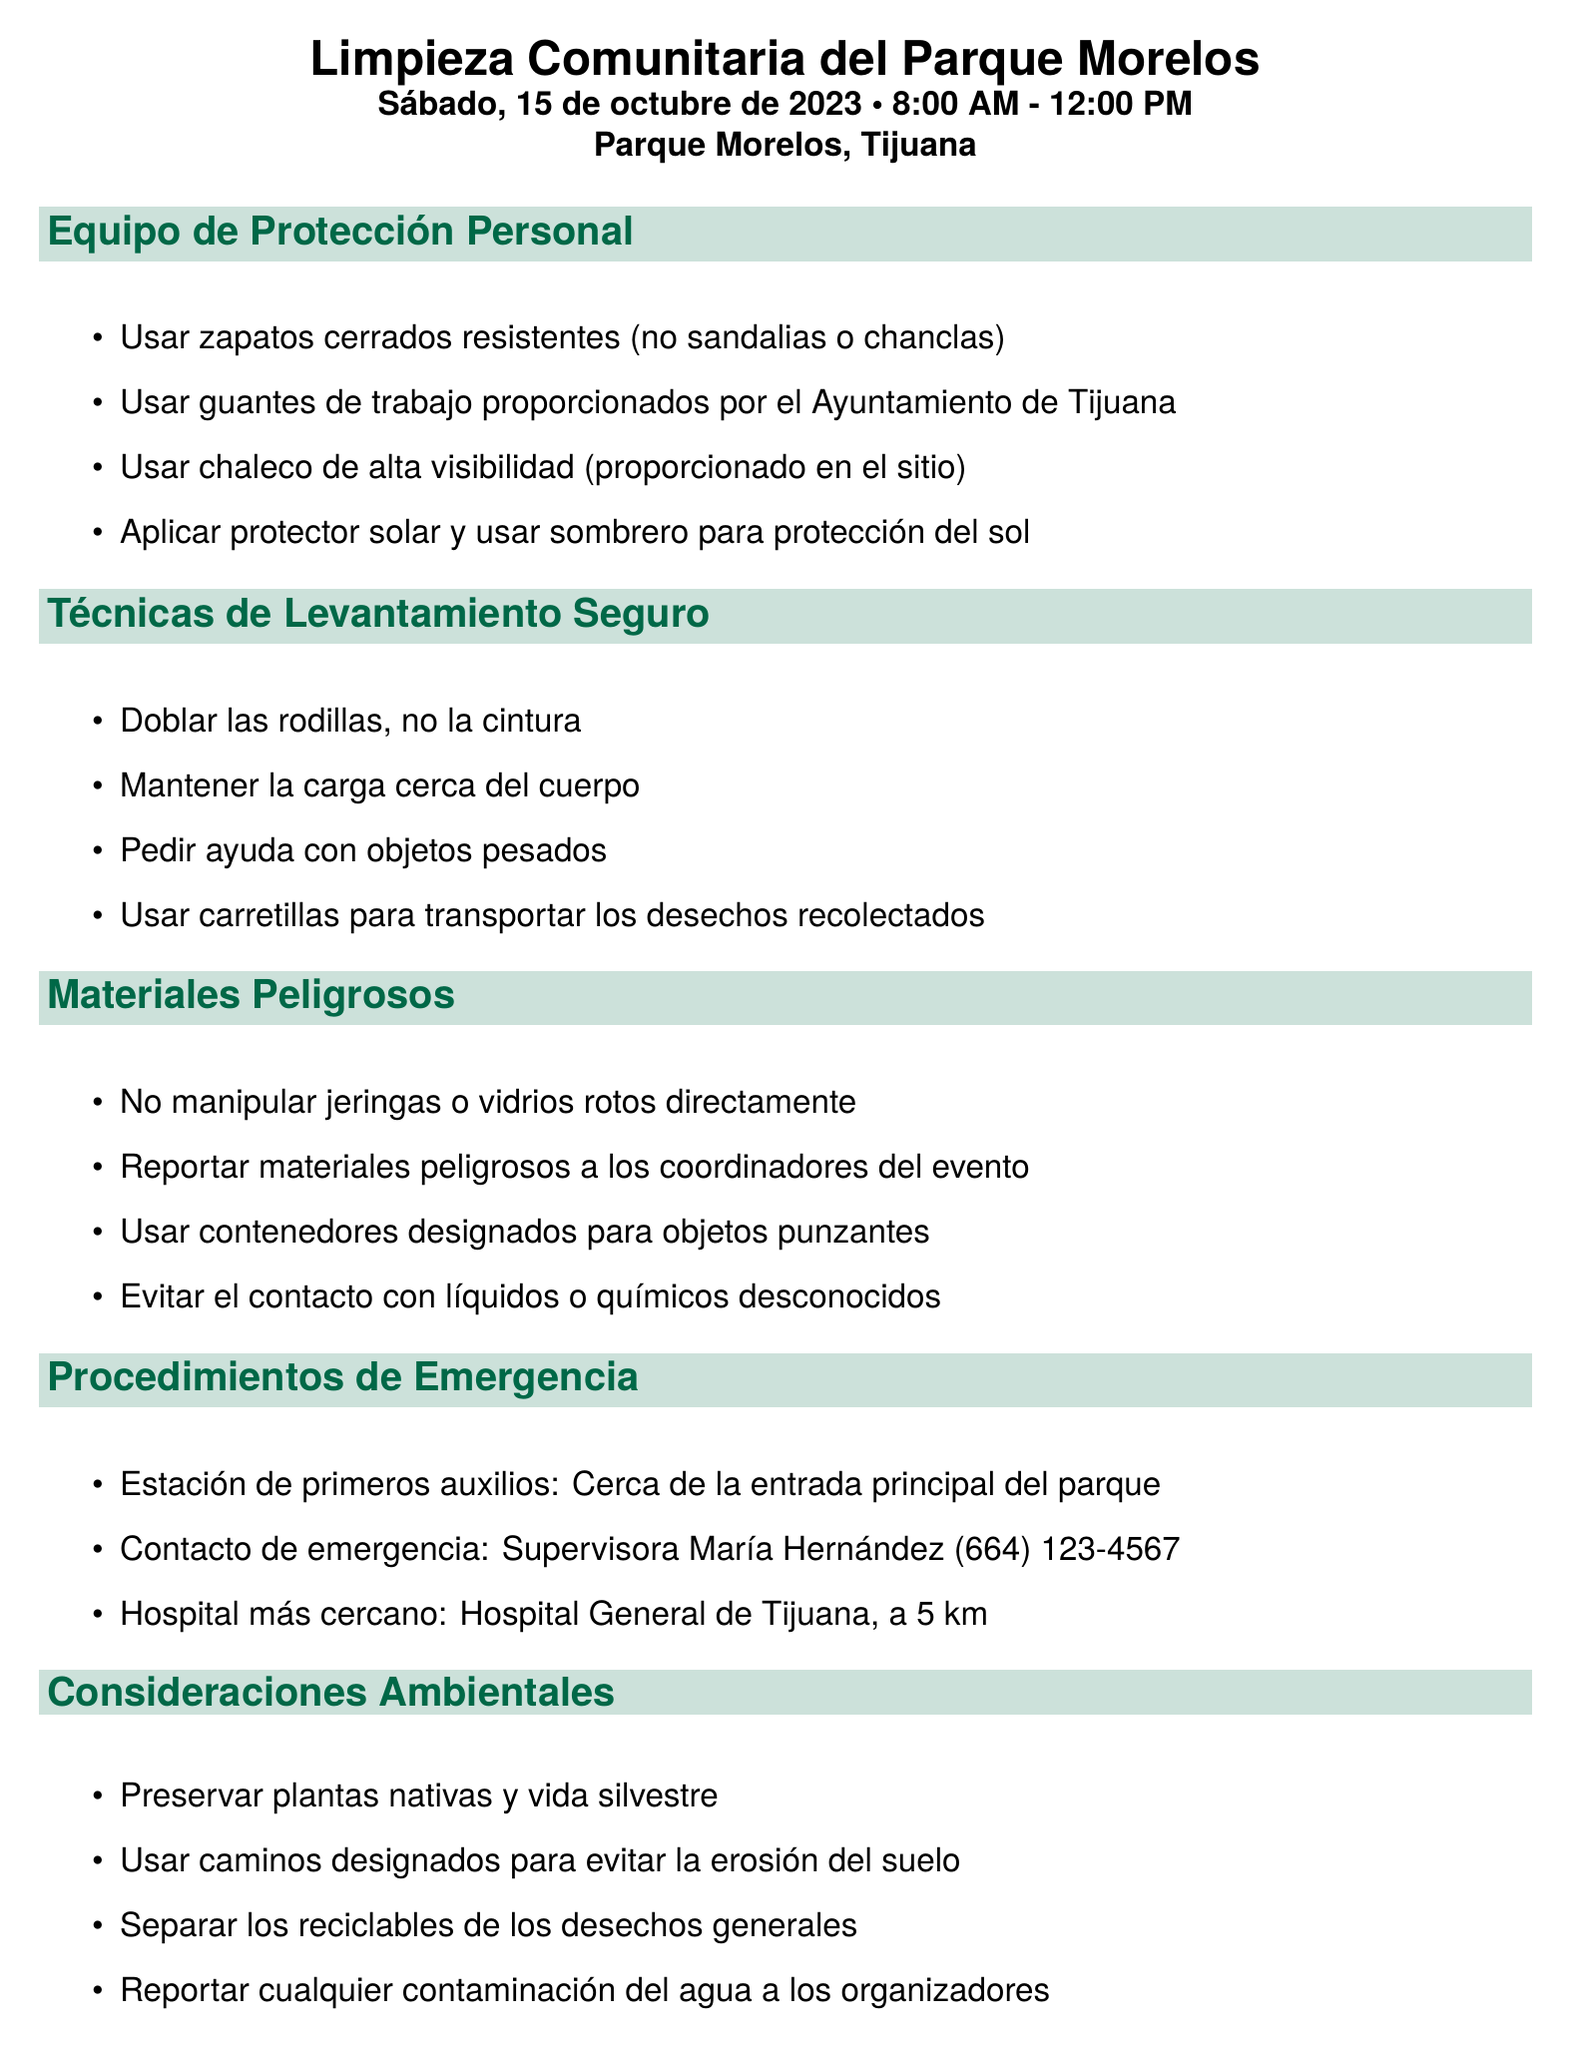What is the name of the event? The name of the event is mentioned in the document as "Parque Morelos Community Clean-up."
Answer: Parque Morelos Community Clean-up What date is the event scheduled? The date of the event is clearly stated in the document.
Answer: Saturday, October 15, 2023 Who is the emergency contact for the event? The document specifies the emergency contact as a supervisor.
Answer: María Hernández What time does the clean-up start? The starting time for the event is provided in the document.
Answer: 8:00 AM What should you do with hazardous materials? Guidelines for handling hazardous materials are outlined in the document.
Answer: Report hazardous materials to event coordinators What should you wear for sun protection? The document mentions specific personal protective equipment related to sun exposure.
Answer: Apply sunscreen and wear a hat What should you bring as personal items? The document lists items participants should bring personally.
Answer: Water bottle, snacks, hand sanitizer, personal medication if needed What is the nearest hospital? The document states the nearest hospital to the event location.
Answer: Hospital General de Tijuana What should you do at the end of the event? The post-event procedures include several actions specified in the document.
Answer: Return all borrowed equipment to the designated area 